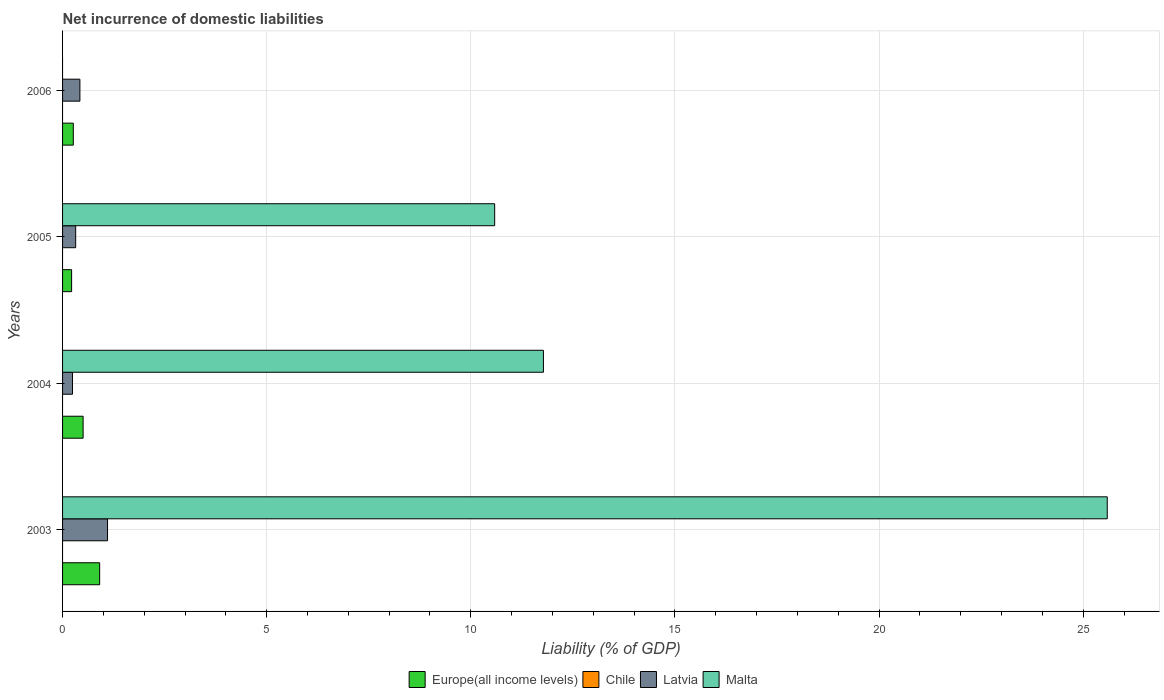How many different coloured bars are there?
Provide a short and direct response. 3. Are the number of bars per tick equal to the number of legend labels?
Your response must be concise. No. Are the number of bars on each tick of the Y-axis equal?
Provide a short and direct response. No. In how many cases, is the number of bars for a given year not equal to the number of legend labels?
Keep it short and to the point. 4. What is the net incurrence of domestic liabilities in Europe(all income levels) in 2004?
Make the answer very short. 0.5. Across all years, what is the maximum net incurrence of domestic liabilities in Latvia?
Ensure brevity in your answer.  1.1. Across all years, what is the minimum net incurrence of domestic liabilities in Chile?
Provide a succinct answer. 0. In which year was the net incurrence of domestic liabilities in Europe(all income levels) maximum?
Your response must be concise. 2003. What is the total net incurrence of domestic liabilities in Europe(all income levels) in the graph?
Your response must be concise. 1.9. What is the difference between the net incurrence of domestic liabilities in Latvia in 2003 and that in 2005?
Your response must be concise. 0.78. What is the average net incurrence of domestic liabilities in Latvia per year?
Provide a short and direct response. 0.52. In the year 2003, what is the difference between the net incurrence of domestic liabilities in Malta and net incurrence of domestic liabilities in Latvia?
Give a very brief answer. 24.49. In how many years, is the net incurrence of domestic liabilities in Europe(all income levels) greater than 23 %?
Your response must be concise. 0. What is the ratio of the net incurrence of domestic liabilities in Latvia in 2004 to that in 2005?
Your response must be concise. 0.76. Is the difference between the net incurrence of domestic liabilities in Malta in 2004 and 2005 greater than the difference between the net incurrence of domestic liabilities in Latvia in 2004 and 2005?
Keep it short and to the point. Yes. What is the difference between the highest and the second highest net incurrence of domestic liabilities in Malta?
Your answer should be compact. 13.81. What is the difference between the highest and the lowest net incurrence of domestic liabilities in Malta?
Keep it short and to the point. 25.59. In how many years, is the net incurrence of domestic liabilities in Latvia greater than the average net incurrence of domestic liabilities in Latvia taken over all years?
Your answer should be compact. 1. How many bars are there?
Keep it short and to the point. 11. Are all the bars in the graph horizontal?
Offer a very short reply. Yes. Are the values on the major ticks of X-axis written in scientific E-notation?
Your answer should be very brief. No. Does the graph contain grids?
Your answer should be very brief. Yes. What is the title of the graph?
Your response must be concise. Net incurrence of domestic liabilities. Does "Ethiopia" appear as one of the legend labels in the graph?
Offer a very short reply. No. What is the label or title of the X-axis?
Keep it short and to the point. Liability (% of GDP). What is the label or title of the Y-axis?
Keep it short and to the point. Years. What is the Liability (% of GDP) of Europe(all income levels) in 2003?
Give a very brief answer. 0.91. What is the Liability (% of GDP) of Chile in 2003?
Offer a very short reply. 0. What is the Liability (% of GDP) of Latvia in 2003?
Your response must be concise. 1.1. What is the Liability (% of GDP) in Malta in 2003?
Offer a terse response. 25.59. What is the Liability (% of GDP) of Europe(all income levels) in 2004?
Provide a succinct answer. 0.5. What is the Liability (% of GDP) in Chile in 2004?
Offer a very short reply. 0. What is the Liability (% of GDP) in Latvia in 2004?
Offer a terse response. 0.24. What is the Liability (% of GDP) of Malta in 2004?
Your answer should be compact. 11.78. What is the Liability (% of GDP) in Europe(all income levels) in 2005?
Your answer should be compact. 0.22. What is the Liability (% of GDP) of Latvia in 2005?
Offer a very short reply. 0.32. What is the Liability (% of GDP) in Malta in 2005?
Provide a succinct answer. 10.58. What is the Liability (% of GDP) of Europe(all income levels) in 2006?
Your answer should be very brief. 0.26. What is the Liability (% of GDP) of Chile in 2006?
Your answer should be very brief. 0. What is the Liability (% of GDP) of Latvia in 2006?
Your response must be concise. 0.42. Across all years, what is the maximum Liability (% of GDP) in Europe(all income levels)?
Your answer should be compact. 0.91. Across all years, what is the maximum Liability (% of GDP) in Latvia?
Offer a very short reply. 1.1. Across all years, what is the maximum Liability (% of GDP) in Malta?
Offer a very short reply. 25.59. Across all years, what is the minimum Liability (% of GDP) of Europe(all income levels)?
Provide a succinct answer. 0.22. Across all years, what is the minimum Liability (% of GDP) in Latvia?
Your response must be concise. 0.24. What is the total Liability (% of GDP) in Europe(all income levels) in the graph?
Give a very brief answer. 1.9. What is the total Liability (% of GDP) in Chile in the graph?
Ensure brevity in your answer.  0. What is the total Liability (% of GDP) of Latvia in the graph?
Your answer should be compact. 2.09. What is the total Liability (% of GDP) in Malta in the graph?
Offer a terse response. 47.95. What is the difference between the Liability (% of GDP) of Europe(all income levels) in 2003 and that in 2004?
Your answer should be very brief. 0.41. What is the difference between the Liability (% of GDP) of Latvia in 2003 and that in 2004?
Ensure brevity in your answer.  0.86. What is the difference between the Liability (% of GDP) in Malta in 2003 and that in 2004?
Give a very brief answer. 13.81. What is the difference between the Liability (% of GDP) of Europe(all income levels) in 2003 and that in 2005?
Give a very brief answer. 0.69. What is the difference between the Liability (% of GDP) in Latvia in 2003 and that in 2005?
Provide a short and direct response. 0.78. What is the difference between the Liability (% of GDP) of Malta in 2003 and that in 2005?
Offer a very short reply. 15.01. What is the difference between the Liability (% of GDP) of Europe(all income levels) in 2003 and that in 2006?
Make the answer very short. 0.65. What is the difference between the Liability (% of GDP) of Latvia in 2003 and that in 2006?
Provide a succinct answer. 0.68. What is the difference between the Liability (% of GDP) of Europe(all income levels) in 2004 and that in 2005?
Your answer should be compact. 0.28. What is the difference between the Liability (% of GDP) in Latvia in 2004 and that in 2005?
Offer a terse response. -0.08. What is the difference between the Liability (% of GDP) of Malta in 2004 and that in 2005?
Keep it short and to the point. 1.19. What is the difference between the Liability (% of GDP) in Europe(all income levels) in 2004 and that in 2006?
Offer a very short reply. 0.24. What is the difference between the Liability (% of GDP) in Latvia in 2004 and that in 2006?
Offer a terse response. -0.18. What is the difference between the Liability (% of GDP) of Europe(all income levels) in 2005 and that in 2006?
Ensure brevity in your answer.  -0.04. What is the difference between the Liability (% of GDP) in Latvia in 2005 and that in 2006?
Your answer should be compact. -0.1. What is the difference between the Liability (% of GDP) in Europe(all income levels) in 2003 and the Liability (% of GDP) in Latvia in 2004?
Ensure brevity in your answer.  0.67. What is the difference between the Liability (% of GDP) in Europe(all income levels) in 2003 and the Liability (% of GDP) in Malta in 2004?
Provide a succinct answer. -10.87. What is the difference between the Liability (% of GDP) of Latvia in 2003 and the Liability (% of GDP) of Malta in 2004?
Your answer should be compact. -10.68. What is the difference between the Liability (% of GDP) of Europe(all income levels) in 2003 and the Liability (% of GDP) of Latvia in 2005?
Offer a very short reply. 0.59. What is the difference between the Liability (% of GDP) in Europe(all income levels) in 2003 and the Liability (% of GDP) in Malta in 2005?
Your answer should be very brief. -9.68. What is the difference between the Liability (% of GDP) of Latvia in 2003 and the Liability (% of GDP) of Malta in 2005?
Offer a terse response. -9.48. What is the difference between the Liability (% of GDP) of Europe(all income levels) in 2003 and the Liability (% of GDP) of Latvia in 2006?
Offer a terse response. 0.48. What is the difference between the Liability (% of GDP) in Europe(all income levels) in 2004 and the Liability (% of GDP) in Latvia in 2005?
Give a very brief answer. 0.18. What is the difference between the Liability (% of GDP) of Europe(all income levels) in 2004 and the Liability (% of GDP) of Malta in 2005?
Make the answer very short. -10.08. What is the difference between the Liability (% of GDP) of Latvia in 2004 and the Liability (% of GDP) of Malta in 2005?
Your response must be concise. -10.34. What is the difference between the Liability (% of GDP) of Europe(all income levels) in 2004 and the Liability (% of GDP) of Latvia in 2006?
Your answer should be very brief. 0.08. What is the difference between the Liability (% of GDP) in Europe(all income levels) in 2005 and the Liability (% of GDP) in Latvia in 2006?
Ensure brevity in your answer.  -0.2. What is the average Liability (% of GDP) of Europe(all income levels) per year?
Provide a short and direct response. 0.47. What is the average Liability (% of GDP) in Chile per year?
Provide a succinct answer. 0. What is the average Liability (% of GDP) of Latvia per year?
Your answer should be compact. 0.52. What is the average Liability (% of GDP) of Malta per year?
Offer a terse response. 11.99. In the year 2003, what is the difference between the Liability (% of GDP) in Europe(all income levels) and Liability (% of GDP) in Latvia?
Your answer should be compact. -0.19. In the year 2003, what is the difference between the Liability (% of GDP) of Europe(all income levels) and Liability (% of GDP) of Malta?
Offer a terse response. -24.68. In the year 2003, what is the difference between the Liability (% of GDP) in Latvia and Liability (% of GDP) in Malta?
Offer a very short reply. -24.49. In the year 2004, what is the difference between the Liability (% of GDP) in Europe(all income levels) and Liability (% of GDP) in Latvia?
Provide a succinct answer. 0.26. In the year 2004, what is the difference between the Liability (% of GDP) in Europe(all income levels) and Liability (% of GDP) in Malta?
Offer a very short reply. -11.28. In the year 2004, what is the difference between the Liability (% of GDP) in Latvia and Liability (% of GDP) in Malta?
Your response must be concise. -11.53. In the year 2005, what is the difference between the Liability (% of GDP) in Europe(all income levels) and Liability (% of GDP) in Latvia?
Your response must be concise. -0.1. In the year 2005, what is the difference between the Liability (% of GDP) in Europe(all income levels) and Liability (% of GDP) in Malta?
Provide a succinct answer. -10.36. In the year 2005, what is the difference between the Liability (% of GDP) in Latvia and Liability (% of GDP) in Malta?
Your answer should be compact. -10.26. In the year 2006, what is the difference between the Liability (% of GDP) in Europe(all income levels) and Liability (% of GDP) in Latvia?
Keep it short and to the point. -0.16. What is the ratio of the Liability (% of GDP) in Europe(all income levels) in 2003 to that in 2004?
Your answer should be compact. 1.81. What is the ratio of the Liability (% of GDP) in Latvia in 2003 to that in 2004?
Give a very brief answer. 4.52. What is the ratio of the Liability (% of GDP) of Malta in 2003 to that in 2004?
Your answer should be compact. 2.17. What is the ratio of the Liability (% of GDP) of Europe(all income levels) in 2003 to that in 2005?
Offer a terse response. 4.1. What is the ratio of the Liability (% of GDP) of Latvia in 2003 to that in 2005?
Your answer should be very brief. 3.43. What is the ratio of the Liability (% of GDP) of Malta in 2003 to that in 2005?
Your answer should be very brief. 2.42. What is the ratio of the Liability (% of GDP) of Europe(all income levels) in 2003 to that in 2006?
Provide a succinct answer. 3.46. What is the ratio of the Liability (% of GDP) of Latvia in 2003 to that in 2006?
Offer a terse response. 2.59. What is the ratio of the Liability (% of GDP) in Europe(all income levels) in 2004 to that in 2005?
Give a very brief answer. 2.27. What is the ratio of the Liability (% of GDP) in Latvia in 2004 to that in 2005?
Your response must be concise. 0.76. What is the ratio of the Liability (% of GDP) in Malta in 2004 to that in 2005?
Your response must be concise. 1.11. What is the ratio of the Liability (% of GDP) in Europe(all income levels) in 2004 to that in 2006?
Ensure brevity in your answer.  1.91. What is the ratio of the Liability (% of GDP) in Latvia in 2004 to that in 2006?
Offer a very short reply. 0.57. What is the ratio of the Liability (% of GDP) in Europe(all income levels) in 2005 to that in 2006?
Your response must be concise. 0.84. What is the ratio of the Liability (% of GDP) of Latvia in 2005 to that in 2006?
Offer a very short reply. 0.76. What is the difference between the highest and the second highest Liability (% of GDP) of Europe(all income levels)?
Offer a terse response. 0.41. What is the difference between the highest and the second highest Liability (% of GDP) in Latvia?
Ensure brevity in your answer.  0.68. What is the difference between the highest and the second highest Liability (% of GDP) in Malta?
Offer a very short reply. 13.81. What is the difference between the highest and the lowest Liability (% of GDP) of Europe(all income levels)?
Provide a short and direct response. 0.69. What is the difference between the highest and the lowest Liability (% of GDP) in Latvia?
Offer a terse response. 0.86. What is the difference between the highest and the lowest Liability (% of GDP) of Malta?
Provide a succinct answer. 25.59. 